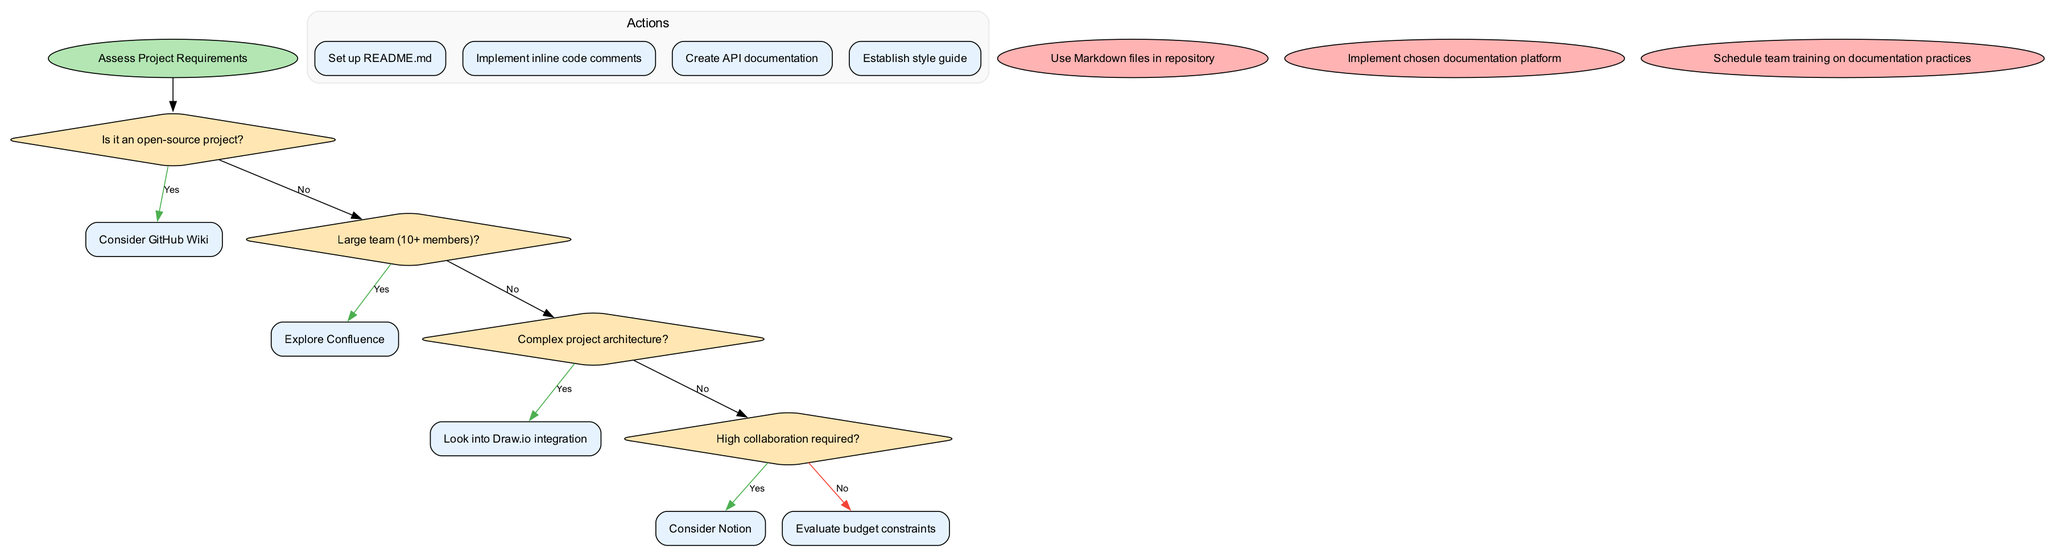What is the starting node in the flowchart? The starting node, indicated at the top of the flowchart, is “Assess Project Requirements.”
Answer: Assess Project Requirements How many decisions are presented in the flowchart? By counting the decision nodes in the flowchart, we see there are four distinct questions regarding project requirements.
Answer: 4 What tool is recommended if the project is open-source? If the project is open-source, the flowchart suggests to “Consider GitHub Wiki” as the documentation tool.
Answer: Consider GitHub Wiki What happens if the team size is large (10+ members)? If the team size is large, the flowchart leads you to explore “Confluence” as the appropriate documentation tool.
Answer: Explore Confluence What should be done if high collaboration is required? According to the flowchart, if high collaboration is needed, you should “Consider Notion.”
Answer: Consider Notion What is the final action after implementing the chosen documentation platform? The flowchart indicates that the final action should be to "Schedule team training on documentation practices."
Answer: Schedule team training on documentation practices What action should be established to improve consistency in documentation? The flowchart suggests establishing a “style guide” as an action to improve consistency in documentation.
Answer: Establish style guide If a project has complex architecture, what integration should be looked into? In the flowchart, if the project has complex architecture, the recommendation is to look into “Draw.io integration.”
Answer: Look into Draw.io integration 